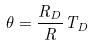<formula> <loc_0><loc_0><loc_500><loc_500>\theta = \frac { R _ { D } } { R } T _ { D }</formula> 